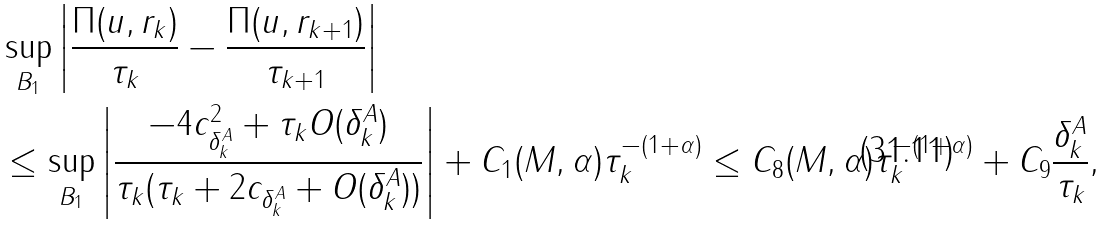Convert formula to latex. <formula><loc_0><loc_0><loc_500><loc_500>& \sup _ { B _ { 1 } } \left | \frac { \Pi ( u , r _ { k } ) } { \tau _ { k } } - \frac { \Pi ( u , r _ { k + 1 } ) } { \tau _ { k + 1 } } \right | \\ & \leq \sup _ { B _ { 1 } } \left | \frac { - 4 c ^ { 2 } _ { \delta ^ { A } _ { k } } + \tau _ { k } O ( \delta ^ { A } _ { k } ) } { \tau _ { k } ( \tau _ { k } + 2 c _ { \delta ^ { A } _ { k } } + O ( \delta ^ { A } _ { k } ) ) } \right | + C _ { 1 } ( M , \alpha ) \tau _ { k } ^ { - ( 1 + \alpha ) } \leq C _ { 8 } ( M , \alpha ) \tau _ { k } ^ { - ( 1 + \alpha ) } + C _ { 9 } \frac { \delta ^ { A } _ { k } } { \tau _ { k } } ,</formula> 